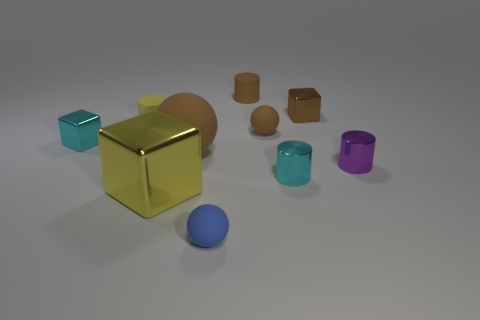There is a shiny thing that is the same color as the big matte thing; what is its shape?
Your answer should be very brief. Cube. How many objects are either spheres behind the large brown matte sphere or tiny objects to the left of the tiny purple metal object?
Provide a succinct answer. 7. Is the color of the tiny block that is to the right of the small cyan metal cylinder the same as the cylinder that is right of the small cyan cylinder?
Your response must be concise. No. What shape is the tiny object that is both left of the yellow metal block and in front of the tiny brown matte ball?
Keep it short and to the point. Cube. There is another metallic block that is the same size as the brown shiny cube; what is its color?
Provide a short and direct response. Cyan. Is there a big metal thing that has the same color as the large cube?
Provide a succinct answer. No. Does the brown rubber ball that is behind the big brown rubber thing have the same size as the brown block that is behind the purple metal cylinder?
Offer a very short reply. Yes. There is a cube that is both in front of the brown cube and on the right side of the tiny yellow thing; what material is it made of?
Your answer should be compact. Metal. How many other objects are the same size as the cyan cube?
Your answer should be compact. 7. There is a tiny cube in front of the small yellow cylinder; what is its material?
Keep it short and to the point. Metal. 